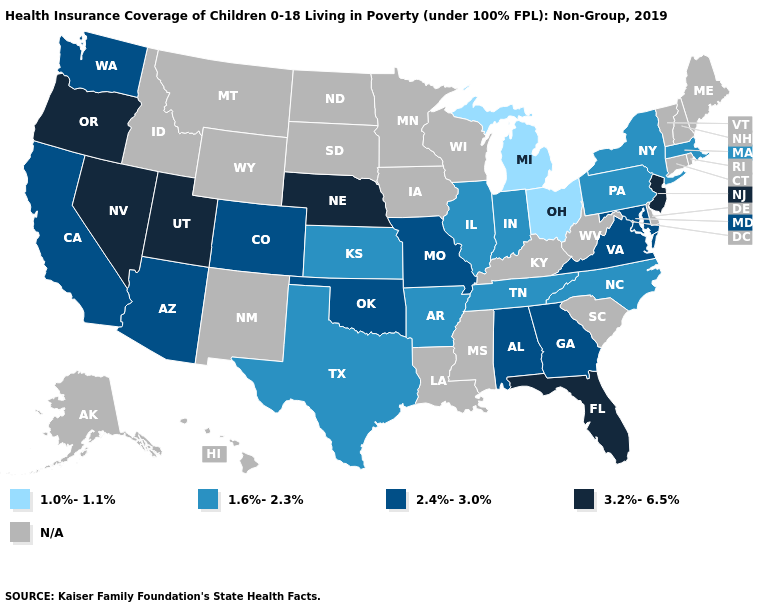Name the states that have a value in the range 3.2%-6.5%?
Quick response, please. Florida, Nebraska, Nevada, New Jersey, Oregon, Utah. What is the lowest value in the MidWest?
Be succinct. 1.0%-1.1%. Which states have the highest value in the USA?
Give a very brief answer. Florida, Nebraska, Nevada, New Jersey, Oregon, Utah. What is the value of New Mexico?
Be succinct. N/A. Name the states that have a value in the range 1.0%-1.1%?
Concise answer only. Michigan, Ohio. Does Nevada have the highest value in the West?
Concise answer only. Yes. Among the states that border Maryland , does Virginia have the lowest value?
Write a very short answer. No. Which states have the lowest value in the USA?
Quick response, please. Michigan, Ohio. What is the lowest value in states that border New Mexico?
Keep it brief. 1.6%-2.3%. Which states hav the highest value in the South?
Write a very short answer. Florida. Name the states that have a value in the range 1.6%-2.3%?
Be succinct. Arkansas, Illinois, Indiana, Kansas, Massachusetts, New York, North Carolina, Pennsylvania, Tennessee, Texas. Which states have the lowest value in the USA?
Write a very short answer. Michigan, Ohio. Among the states that border New Mexico , which have the lowest value?
Answer briefly. Texas. Which states have the highest value in the USA?
Quick response, please. Florida, Nebraska, Nevada, New Jersey, Oregon, Utah. 